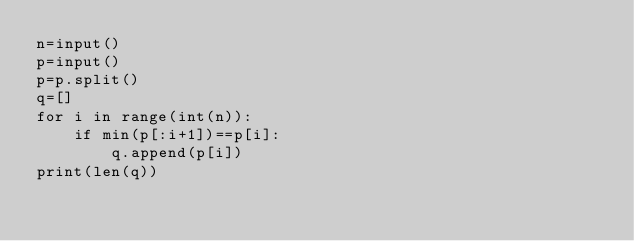<code> <loc_0><loc_0><loc_500><loc_500><_Python_>n=input()
p=input()
p=p.split()
q=[]
for i in range(int(n)):
    if min(p[:i+1])==p[i]:
        q.append(p[i])
print(len(q))</code> 